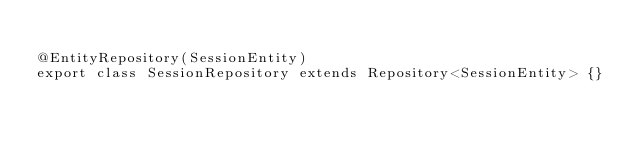Convert code to text. <code><loc_0><loc_0><loc_500><loc_500><_TypeScript_>
@EntityRepository(SessionEntity)
export class SessionRepository extends Repository<SessionEntity> {}
</code> 